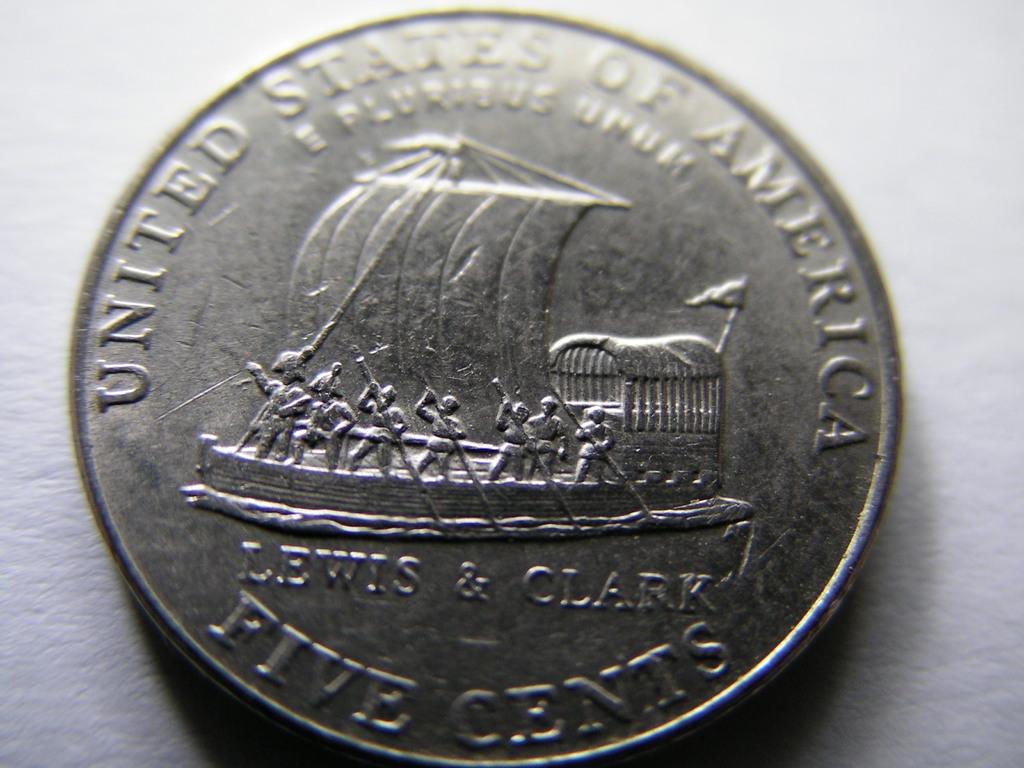How much is this coin worth?
Provide a short and direct response. Five cents. What country does this coin come from?
Provide a succinct answer. United states. 